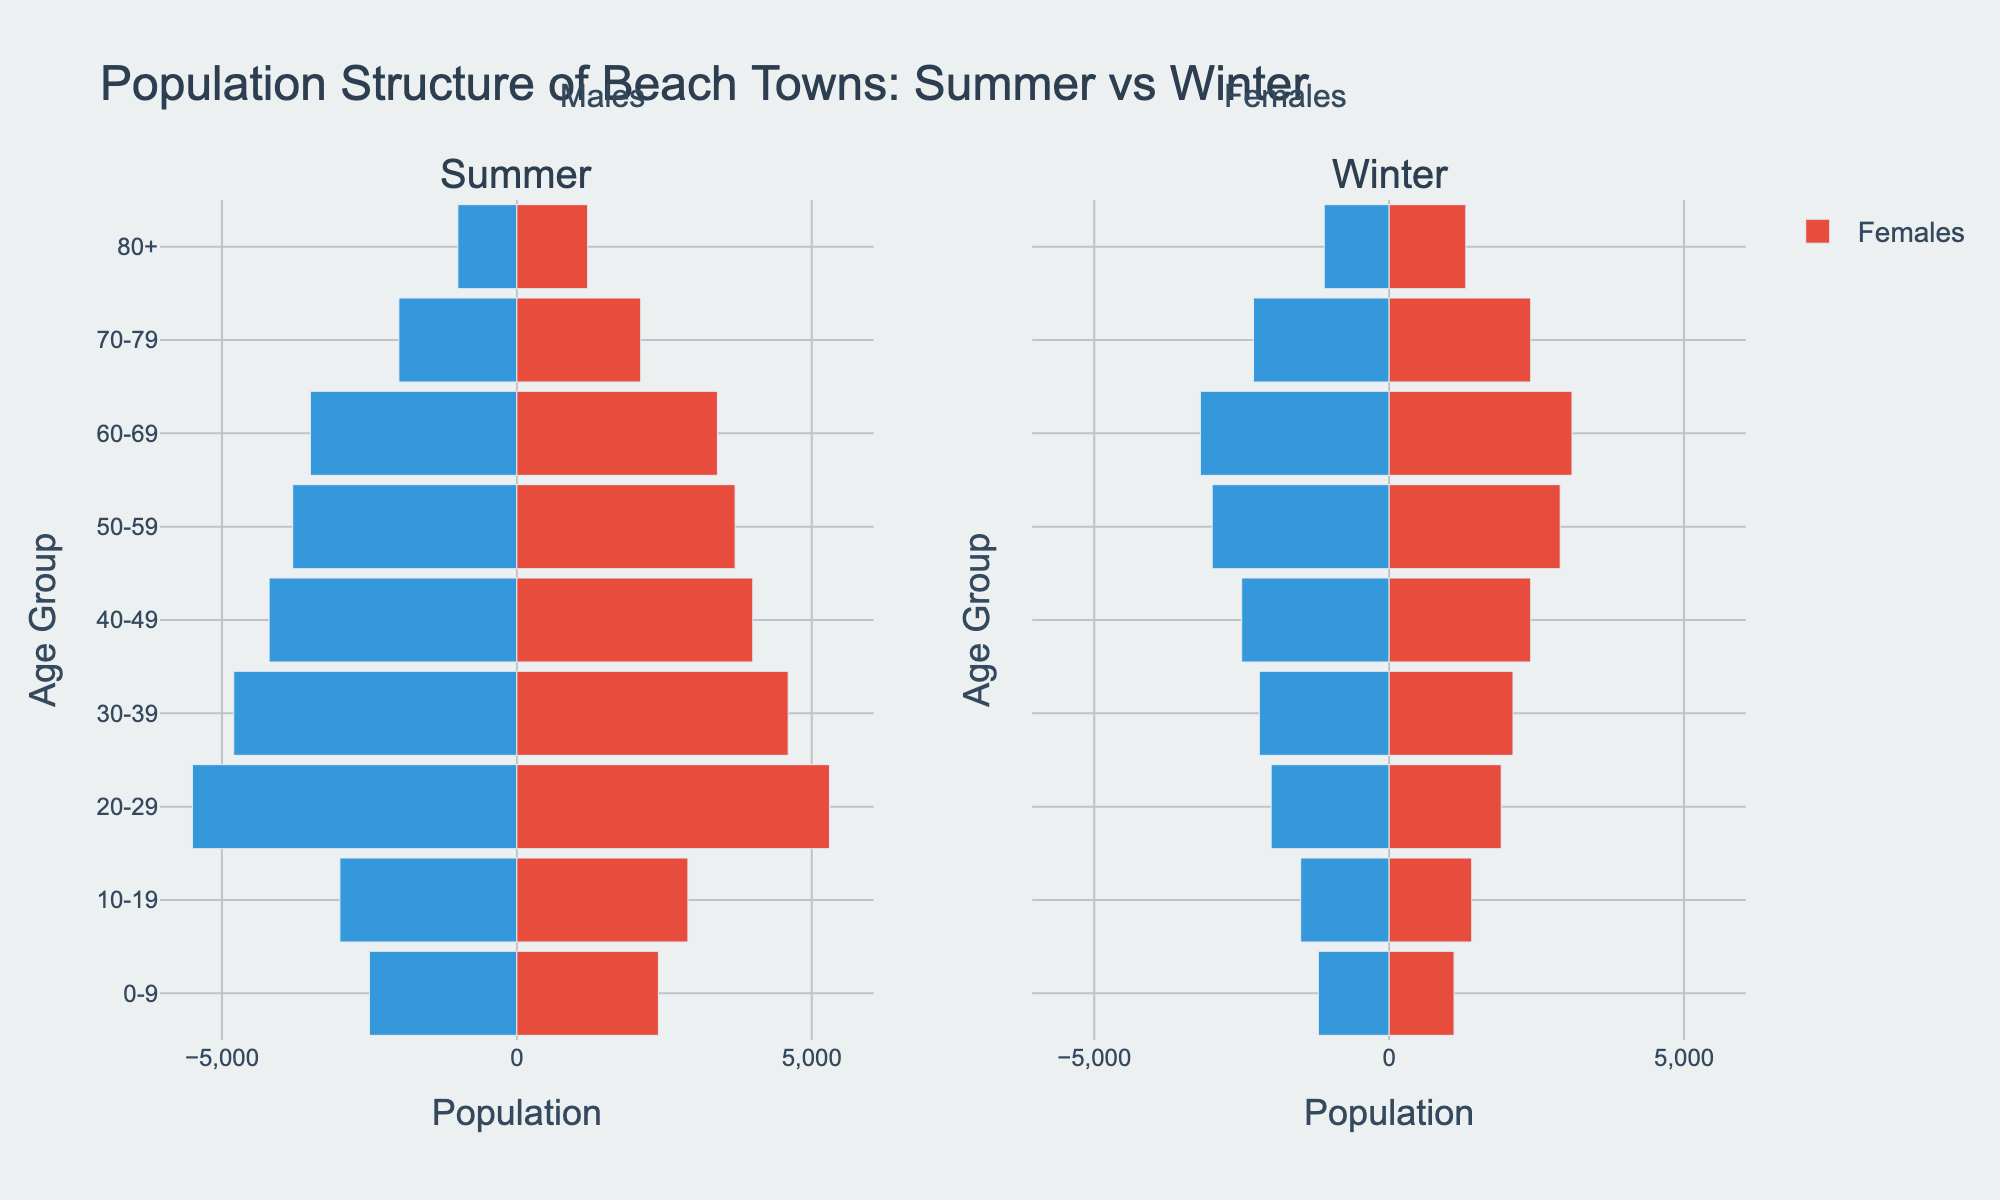What is the title of the figure? The title is typically located at the top of the plot and is meant to describe what the figure is about. In this case, at the top of the chart, the title reads "Population Structure of Beach Towns: Summer vs Winter".
Answer: Population Structure of Beach Towns: Summer vs Winter What are the age groups represented in the figure? The age groups can be found on the y-axis of the figure. They are represented from top to bottom and include "0-9", "10-19", "20-29", "30-39", "40-49", "50-59", "60-69", "70-79", and "80+".
Answer: 0-9, 10-19, 20-29, 30-39, 40-49, 50-59, 60-69, 70-79, 80+ Which gender has the highest population in the "20-29" age group during summer? For the age group "20-29" during summer, look at the bars extending to the left for males and to the right for females in the "Summer" section of the figure. The male bar extends further than the female bar.
Answer: Males How does the population of "30-39" age group females in winter compare to that in summer? In the "30-39" age group, compare the bar for females in the "Winter" section to the one in the "Summer" section. The summer females' bar extends further compared to the winter females' bar.
Answer: Lower in winter What is the total population of males and females in the "50-59" age group during winter? To find the total population, sum the population of males and females in the "50-59" age group during winter. The values are 3000 (males) + 2900 (females).
Answer: 5900 Which age group has the most considerable increase in the male population from winter to summer? Compare the difference in male population for each age group between winter and summer. The "20-29" age group shows the most considerable increase, from 2000 in winter to 5500 in summer.
Answer: 20-29 Are there more females aged "80+" in winter or in summer? Look at the length of the bars for females aged "80+" in both the "Winter" and "Summer" sections. The bar for winter extends further than the bar for summer.
Answer: Winter How does the "60-69" male population in summer compare to the "60-69" female population in winter? For the age group "60-69", compare the bar for males in the "Summer" section with the bar for females in the "Winter" section. The bar for summer males is slightly longer than the bar for winter females.
Answer: Higher in summer What is the difference in the male population of "70-79" age group between winter and summer? Subtract the population of males aged "70-79" during winter (2300) from their population during summer (2000). The difference is 2000 - 2300 = -300.
Answer: -300 In which season and age group do we see the highest population for any gender? Look for the longest bar in either section. The "20-29" males during summer have the highest population bar length.
Answer: 20-29 males in summer 